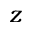<formula> <loc_0><loc_0><loc_500><loc_500>z</formula> 